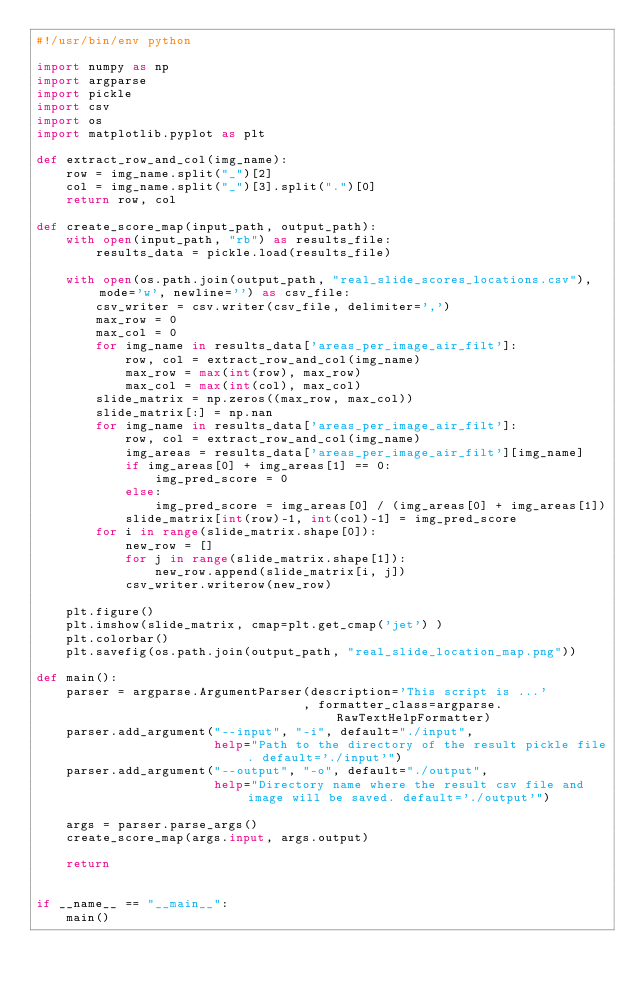<code> <loc_0><loc_0><loc_500><loc_500><_Python_>#!/usr/bin/env python

import numpy as np
import argparse
import pickle
import csv
import os
import matplotlib.pyplot as plt

def extract_row_and_col(img_name):
    row = img_name.split("_")[2]
    col = img_name.split("_")[3].split(".")[0]
    return row, col

def create_score_map(input_path, output_path):
    with open(input_path, "rb") as results_file:
        results_data = pickle.load(results_file)

    with open(os.path.join(output_path, "real_slide_scores_locations.csv"), mode='w', newline='') as csv_file:
        csv_writer = csv.writer(csv_file, delimiter=',')
        max_row = 0
        max_col = 0
        for img_name in results_data['areas_per_image_air_filt']:
            row, col = extract_row_and_col(img_name)
            max_row = max(int(row), max_row)
            max_col = max(int(col), max_col)
        slide_matrix = np.zeros((max_row, max_col))
        slide_matrix[:] = np.nan
        for img_name in results_data['areas_per_image_air_filt']:
            row, col = extract_row_and_col(img_name)
            img_areas = results_data['areas_per_image_air_filt'][img_name]
            if img_areas[0] + img_areas[1] == 0:
                img_pred_score = 0
            else:
                img_pred_score = img_areas[0] / (img_areas[0] + img_areas[1])
            slide_matrix[int(row)-1, int(col)-1] = img_pred_score
        for i in range(slide_matrix.shape[0]):
            new_row = []
            for j in range(slide_matrix.shape[1]):
                new_row.append(slide_matrix[i, j])
            csv_writer.writerow(new_row)
            
    plt.figure()
    plt.imshow(slide_matrix, cmap=plt.get_cmap('jet') )
    plt.colorbar()
    plt.savefig(os.path.join(output_path, "real_slide_location_map.png"))
        
def main():
    parser = argparse.ArgumentParser(description='This script is ...'
                                    , formatter_class=argparse.RawTextHelpFormatter)
    parser.add_argument("--input", "-i", default="./input",
                        help="Path to the directory of the result pickle file. default='./input'")
    parser.add_argument("--output", "-o", default="./output",
                        help="Directory name where the result csv file and image will be saved. default='./output'")

    args = parser.parse_args()
    create_score_map(args.input, args.output)
    
    return


if __name__ == "__main__":
    main()
</code> 